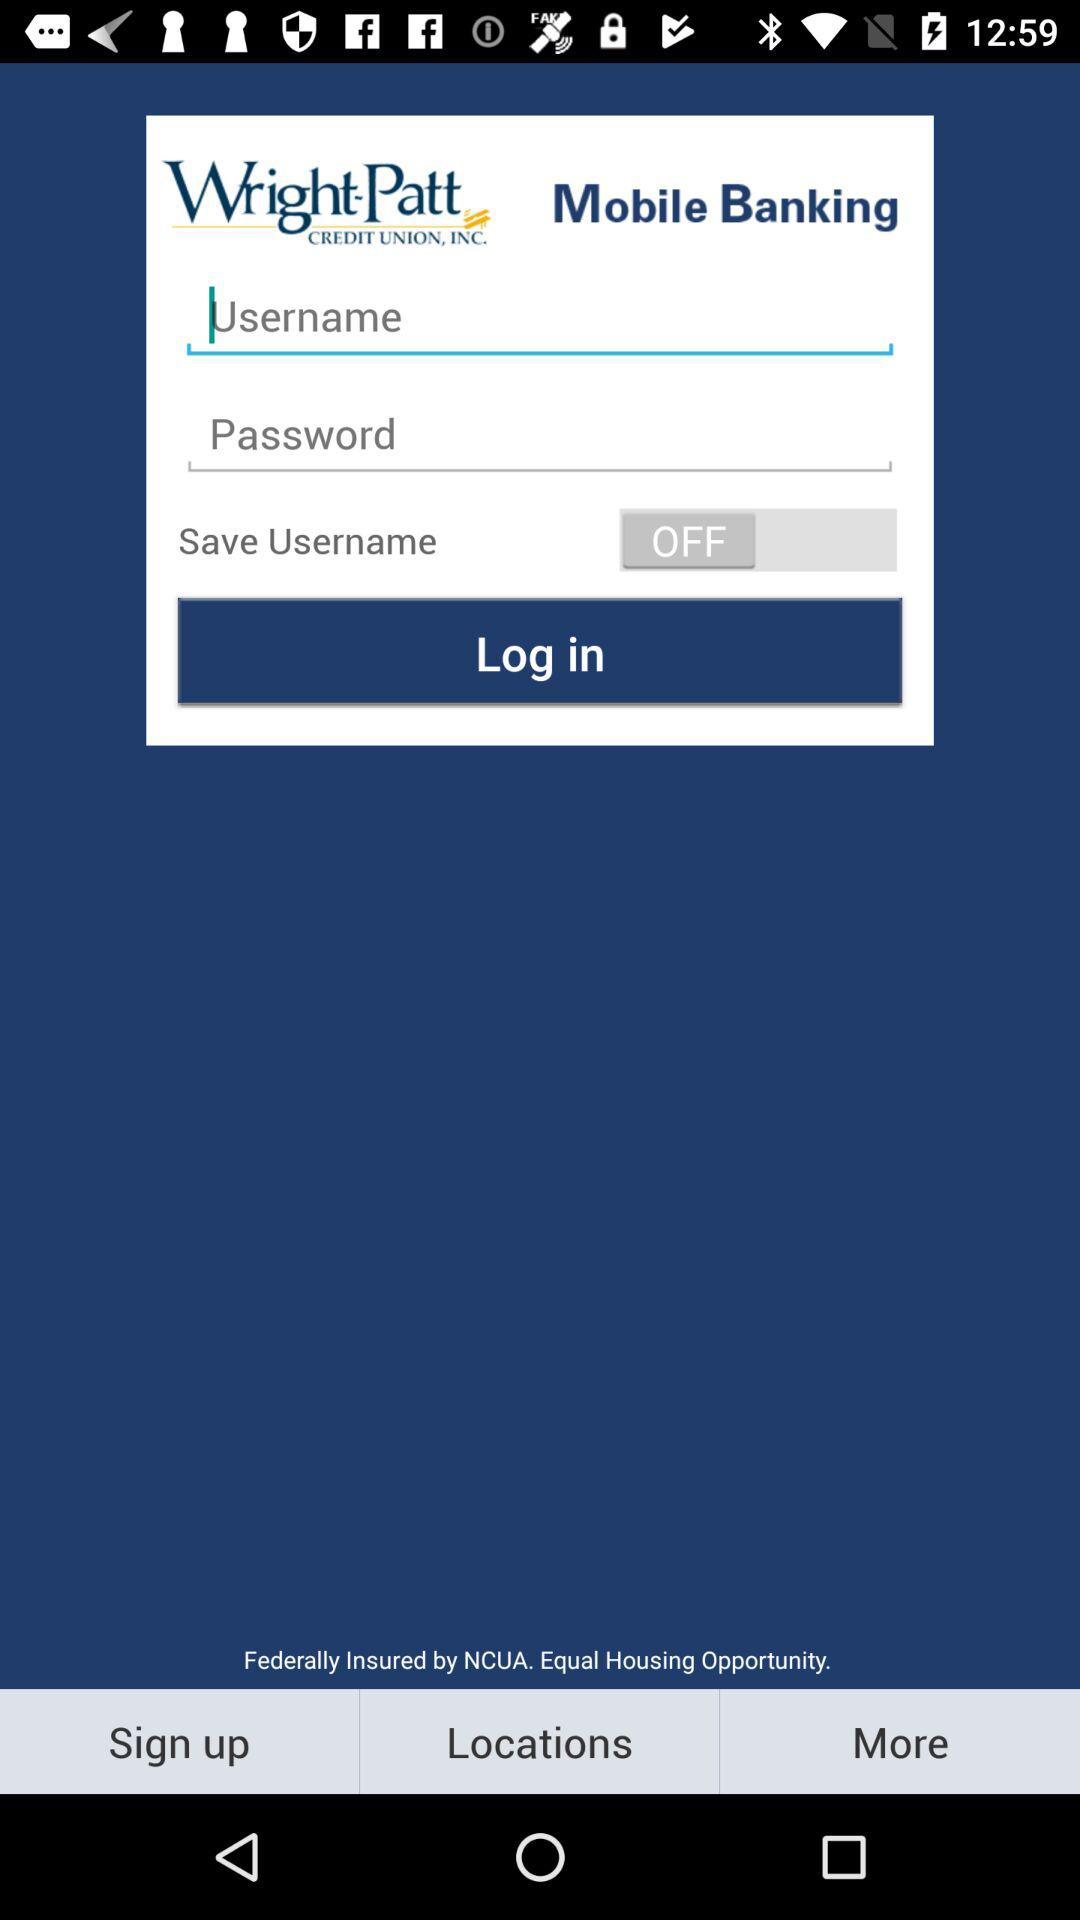What is the status of "Save Username"? The status is "off". 